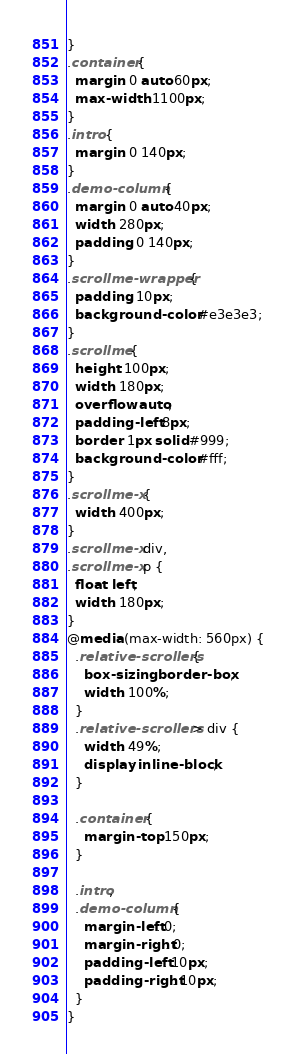<code> <loc_0><loc_0><loc_500><loc_500><_CSS_>}
.container {
  margin: 0 auto 60px;
  max-width: 1100px;
}
.intro {
  margin: 0 140px;
}
.demo-column {
  margin: 0 auto 40px;
  width: 280px;
  padding: 0 140px;
}
.scrollme-wrapper {
  padding: 10px;
  background-color: #e3e3e3;
}
.scrollme {
  height: 100px;
  width: 180px;
  overflow: auto;
  padding-left: 8px;
  border: 1px solid #999;
  background-color: #fff;
}
.scrollme-x {
  width: 400px;
}
.scrollme-x div,
.scrollme-x p {
  float: left;
  width: 180px;
}
@media (max-width: 560px) {
  .relative-scrollers {
    box-sizing: border-box;
    width: 100%;
  }
  .relative-scrollers > div {
    width: 49%;
    display: inline-block;
  }

  .container {
    margin-top: 150px;
  }

  .intro,
  .demo-column {
    margin-left: 0;
    margin-right: 0;
    padding-left: 10px;
    padding-right: 10px;
  }
}
</code> 